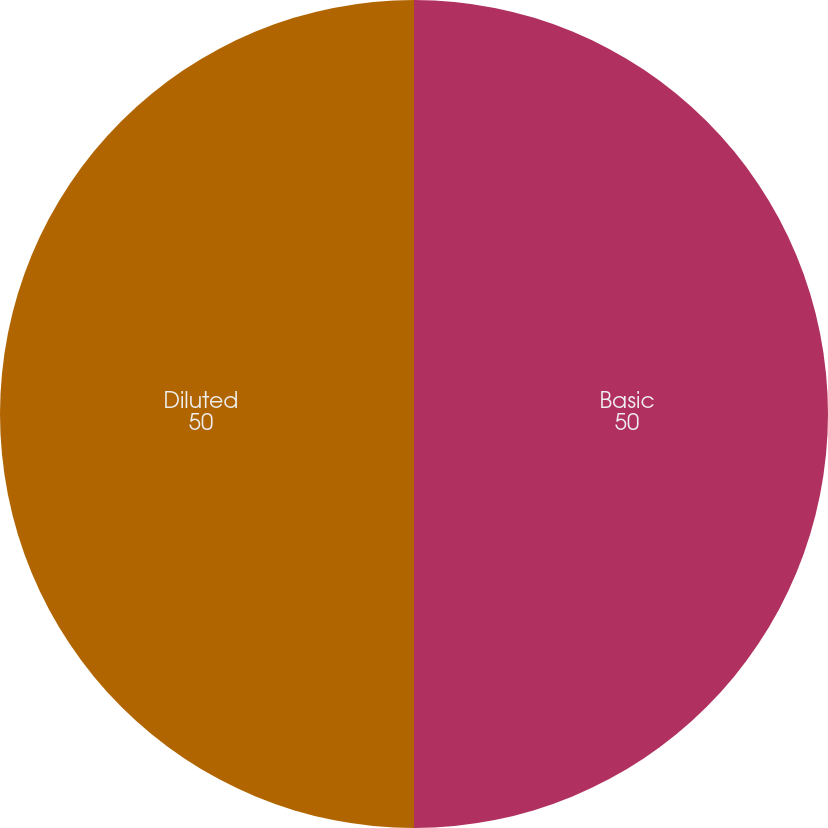Convert chart to OTSL. <chart><loc_0><loc_0><loc_500><loc_500><pie_chart><fcel>Basic<fcel>Diluted<nl><fcel>50.0%<fcel>50.0%<nl></chart> 